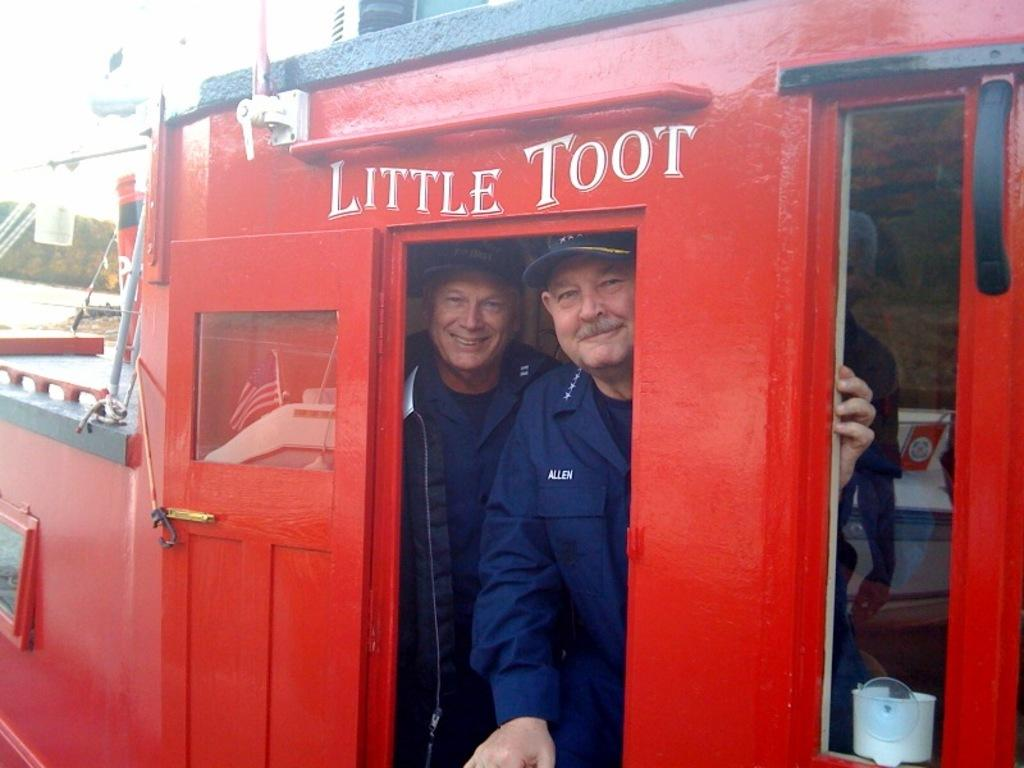How many people are in the image? There are two persons in the image. Where are the two persons located? The two persons are standing in a cabin. What is unique about the location of the cabin? The cabin is off a boat. What type of animal can be seen partying with the two persons in the image? There are no animals present in the image, and no party is depicted. 